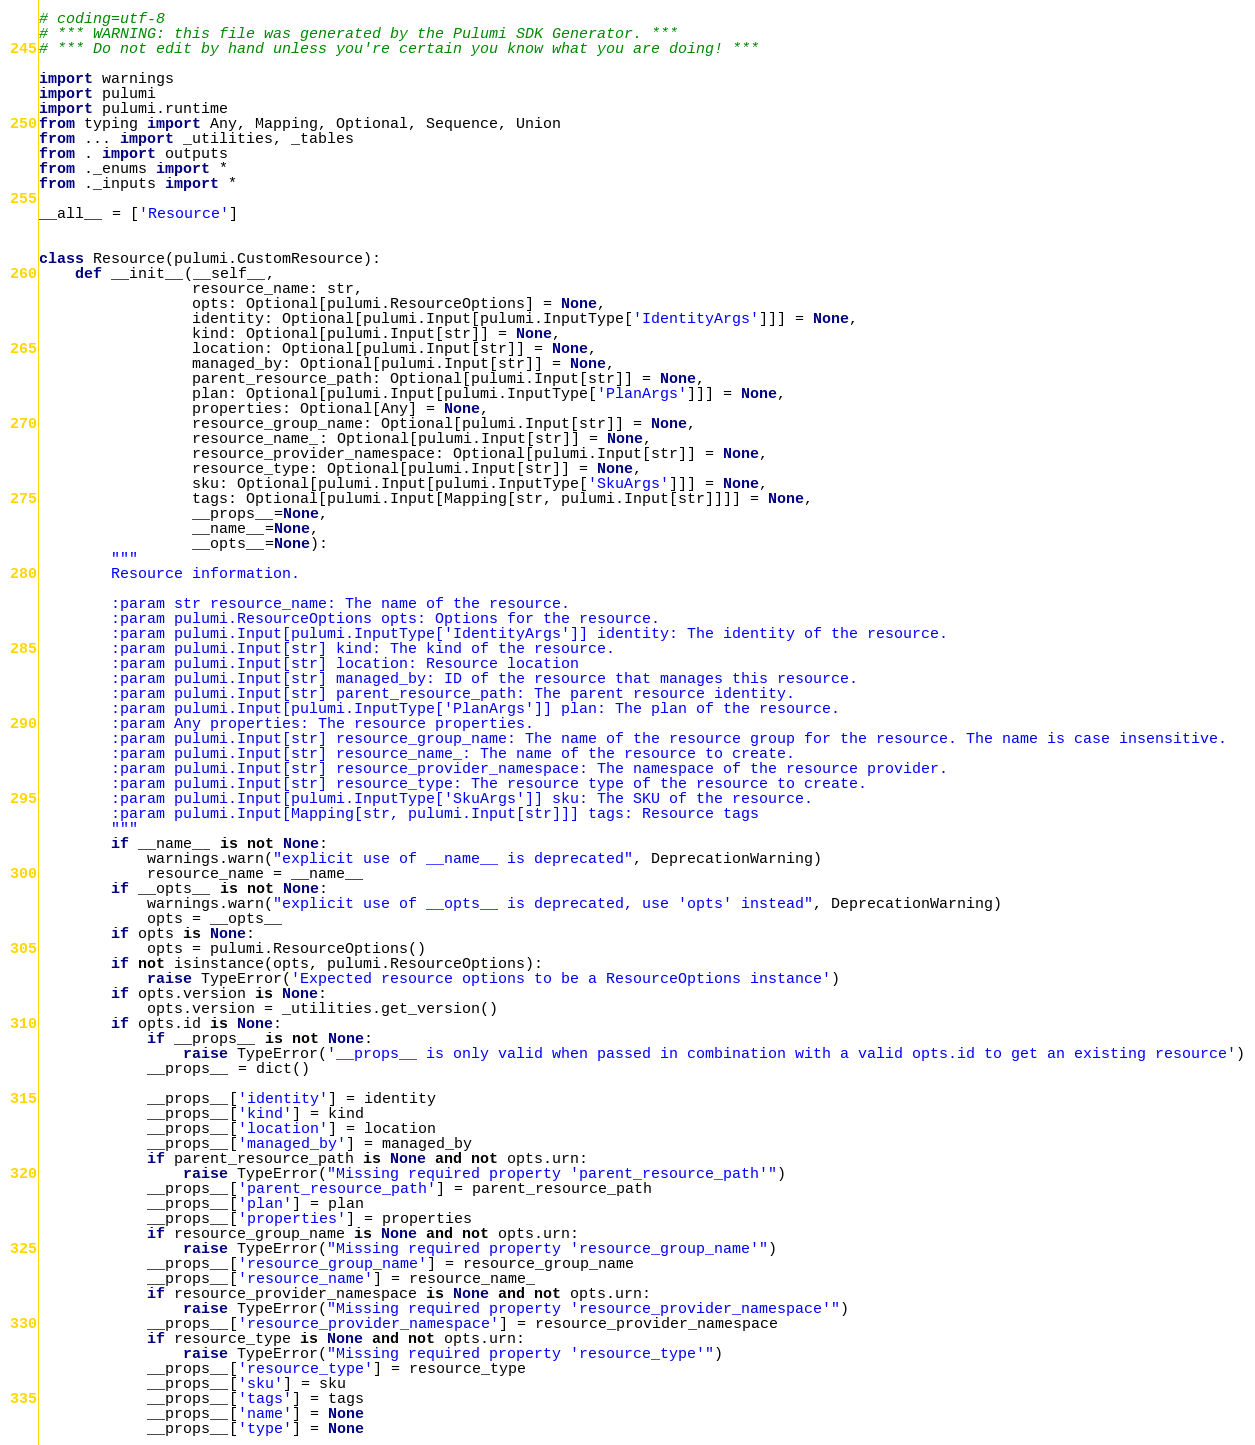Convert code to text. <code><loc_0><loc_0><loc_500><loc_500><_Python_># coding=utf-8
# *** WARNING: this file was generated by the Pulumi SDK Generator. ***
# *** Do not edit by hand unless you're certain you know what you are doing! ***

import warnings
import pulumi
import pulumi.runtime
from typing import Any, Mapping, Optional, Sequence, Union
from ... import _utilities, _tables
from . import outputs
from ._enums import *
from ._inputs import *

__all__ = ['Resource']


class Resource(pulumi.CustomResource):
    def __init__(__self__,
                 resource_name: str,
                 opts: Optional[pulumi.ResourceOptions] = None,
                 identity: Optional[pulumi.Input[pulumi.InputType['IdentityArgs']]] = None,
                 kind: Optional[pulumi.Input[str]] = None,
                 location: Optional[pulumi.Input[str]] = None,
                 managed_by: Optional[pulumi.Input[str]] = None,
                 parent_resource_path: Optional[pulumi.Input[str]] = None,
                 plan: Optional[pulumi.Input[pulumi.InputType['PlanArgs']]] = None,
                 properties: Optional[Any] = None,
                 resource_group_name: Optional[pulumi.Input[str]] = None,
                 resource_name_: Optional[pulumi.Input[str]] = None,
                 resource_provider_namespace: Optional[pulumi.Input[str]] = None,
                 resource_type: Optional[pulumi.Input[str]] = None,
                 sku: Optional[pulumi.Input[pulumi.InputType['SkuArgs']]] = None,
                 tags: Optional[pulumi.Input[Mapping[str, pulumi.Input[str]]]] = None,
                 __props__=None,
                 __name__=None,
                 __opts__=None):
        """
        Resource information.

        :param str resource_name: The name of the resource.
        :param pulumi.ResourceOptions opts: Options for the resource.
        :param pulumi.Input[pulumi.InputType['IdentityArgs']] identity: The identity of the resource.
        :param pulumi.Input[str] kind: The kind of the resource.
        :param pulumi.Input[str] location: Resource location
        :param pulumi.Input[str] managed_by: ID of the resource that manages this resource.
        :param pulumi.Input[str] parent_resource_path: The parent resource identity.
        :param pulumi.Input[pulumi.InputType['PlanArgs']] plan: The plan of the resource.
        :param Any properties: The resource properties.
        :param pulumi.Input[str] resource_group_name: The name of the resource group for the resource. The name is case insensitive.
        :param pulumi.Input[str] resource_name_: The name of the resource to create.
        :param pulumi.Input[str] resource_provider_namespace: The namespace of the resource provider.
        :param pulumi.Input[str] resource_type: The resource type of the resource to create.
        :param pulumi.Input[pulumi.InputType['SkuArgs']] sku: The SKU of the resource.
        :param pulumi.Input[Mapping[str, pulumi.Input[str]]] tags: Resource tags
        """
        if __name__ is not None:
            warnings.warn("explicit use of __name__ is deprecated", DeprecationWarning)
            resource_name = __name__
        if __opts__ is not None:
            warnings.warn("explicit use of __opts__ is deprecated, use 'opts' instead", DeprecationWarning)
            opts = __opts__
        if opts is None:
            opts = pulumi.ResourceOptions()
        if not isinstance(opts, pulumi.ResourceOptions):
            raise TypeError('Expected resource options to be a ResourceOptions instance')
        if opts.version is None:
            opts.version = _utilities.get_version()
        if opts.id is None:
            if __props__ is not None:
                raise TypeError('__props__ is only valid when passed in combination with a valid opts.id to get an existing resource')
            __props__ = dict()

            __props__['identity'] = identity
            __props__['kind'] = kind
            __props__['location'] = location
            __props__['managed_by'] = managed_by
            if parent_resource_path is None and not opts.urn:
                raise TypeError("Missing required property 'parent_resource_path'")
            __props__['parent_resource_path'] = parent_resource_path
            __props__['plan'] = plan
            __props__['properties'] = properties
            if resource_group_name is None and not opts.urn:
                raise TypeError("Missing required property 'resource_group_name'")
            __props__['resource_group_name'] = resource_group_name
            __props__['resource_name'] = resource_name_
            if resource_provider_namespace is None and not opts.urn:
                raise TypeError("Missing required property 'resource_provider_namespace'")
            __props__['resource_provider_namespace'] = resource_provider_namespace
            if resource_type is None and not opts.urn:
                raise TypeError("Missing required property 'resource_type'")
            __props__['resource_type'] = resource_type
            __props__['sku'] = sku
            __props__['tags'] = tags
            __props__['name'] = None
            __props__['type'] = None</code> 